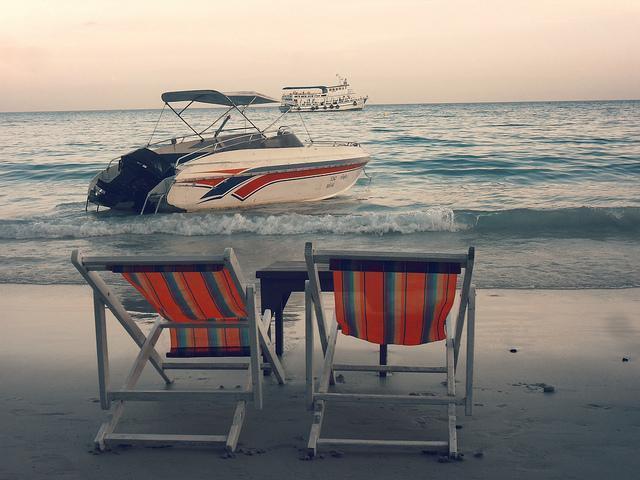How many dining tables are in the photo?
Give a very brief answer. 1. How many chairs can be seen?
Give a very brief answer. 2. How many boats are in the picture?
Give a very brief answer. 2. How many giraffes are in the photo?
Give a very brief answer. 0. 